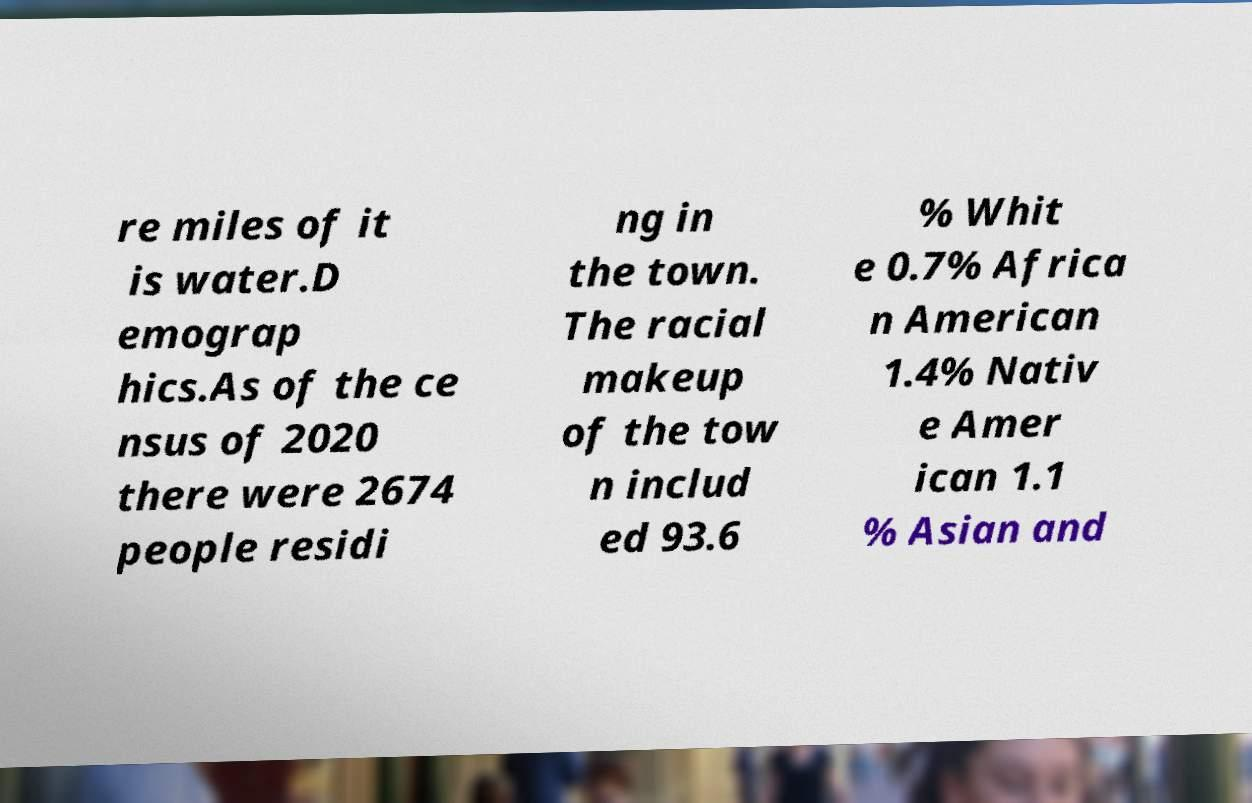Can you read and provide the text displayed in the image?This photo seems to have some interesting text. Can you extract and type it out for me? re miles of it is water.D emograp hics.As of the ce nsus of 2020 there were 2674 people residi ng in the town. The racial makeup of the tow n includ ed 93.6 % Whit e 0.7% Africa n American 1.4% Nativ e Amer ican 1.1 % Asian and 